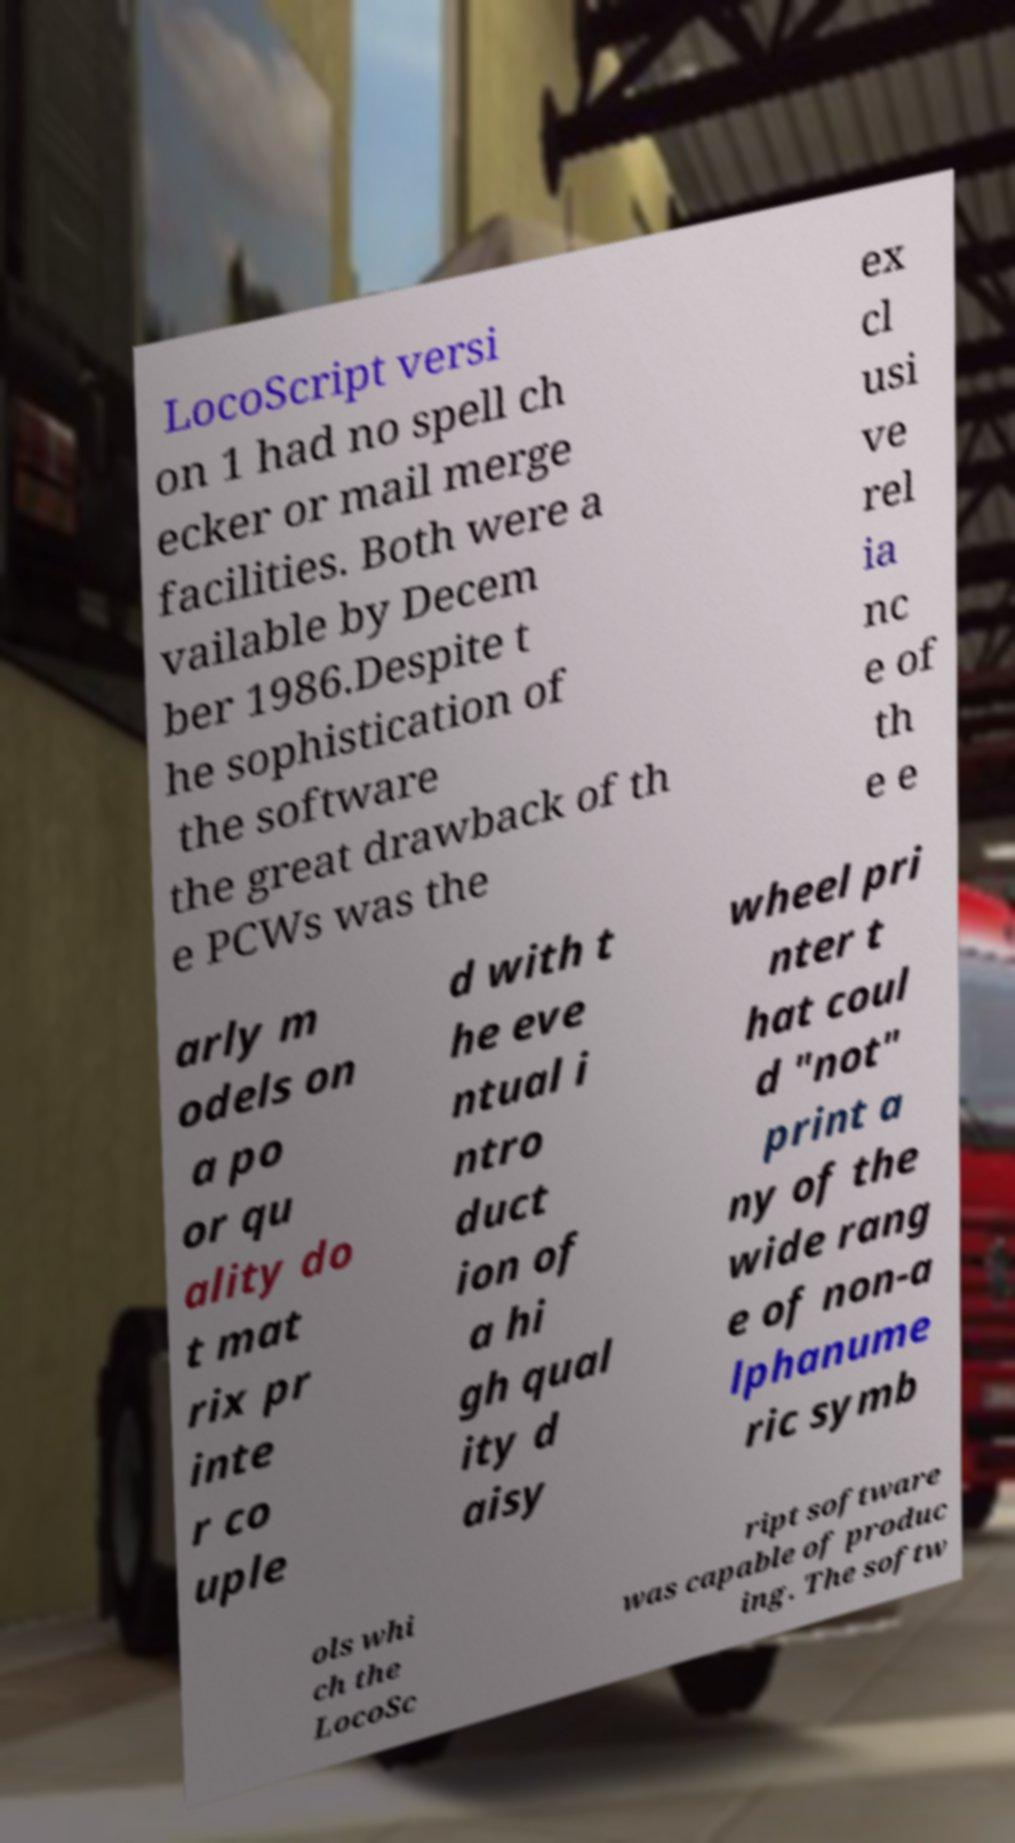Please read and relay the text visible in this image. What does it say? LocoScript versi on 1 had no spell ch ecker or mail merge facilities. Both were a vailable by Decem ber 1986.Despite t he sophistication of the software the great drawback of th e PCWs was the ex cl usi ve rel ia nc e of th e e arly m odels on a po or qu ality do t mat rix pr inte r co uple d with t he eve ntual i ntro duct ion of a hi gh qual ity d aisy wheel pri nter t hat coul d "not" print a ny of the wide rang e of non-a lphanume ric symb ols whi ch the LocoSc ript software was capable of produc ing. The softw 